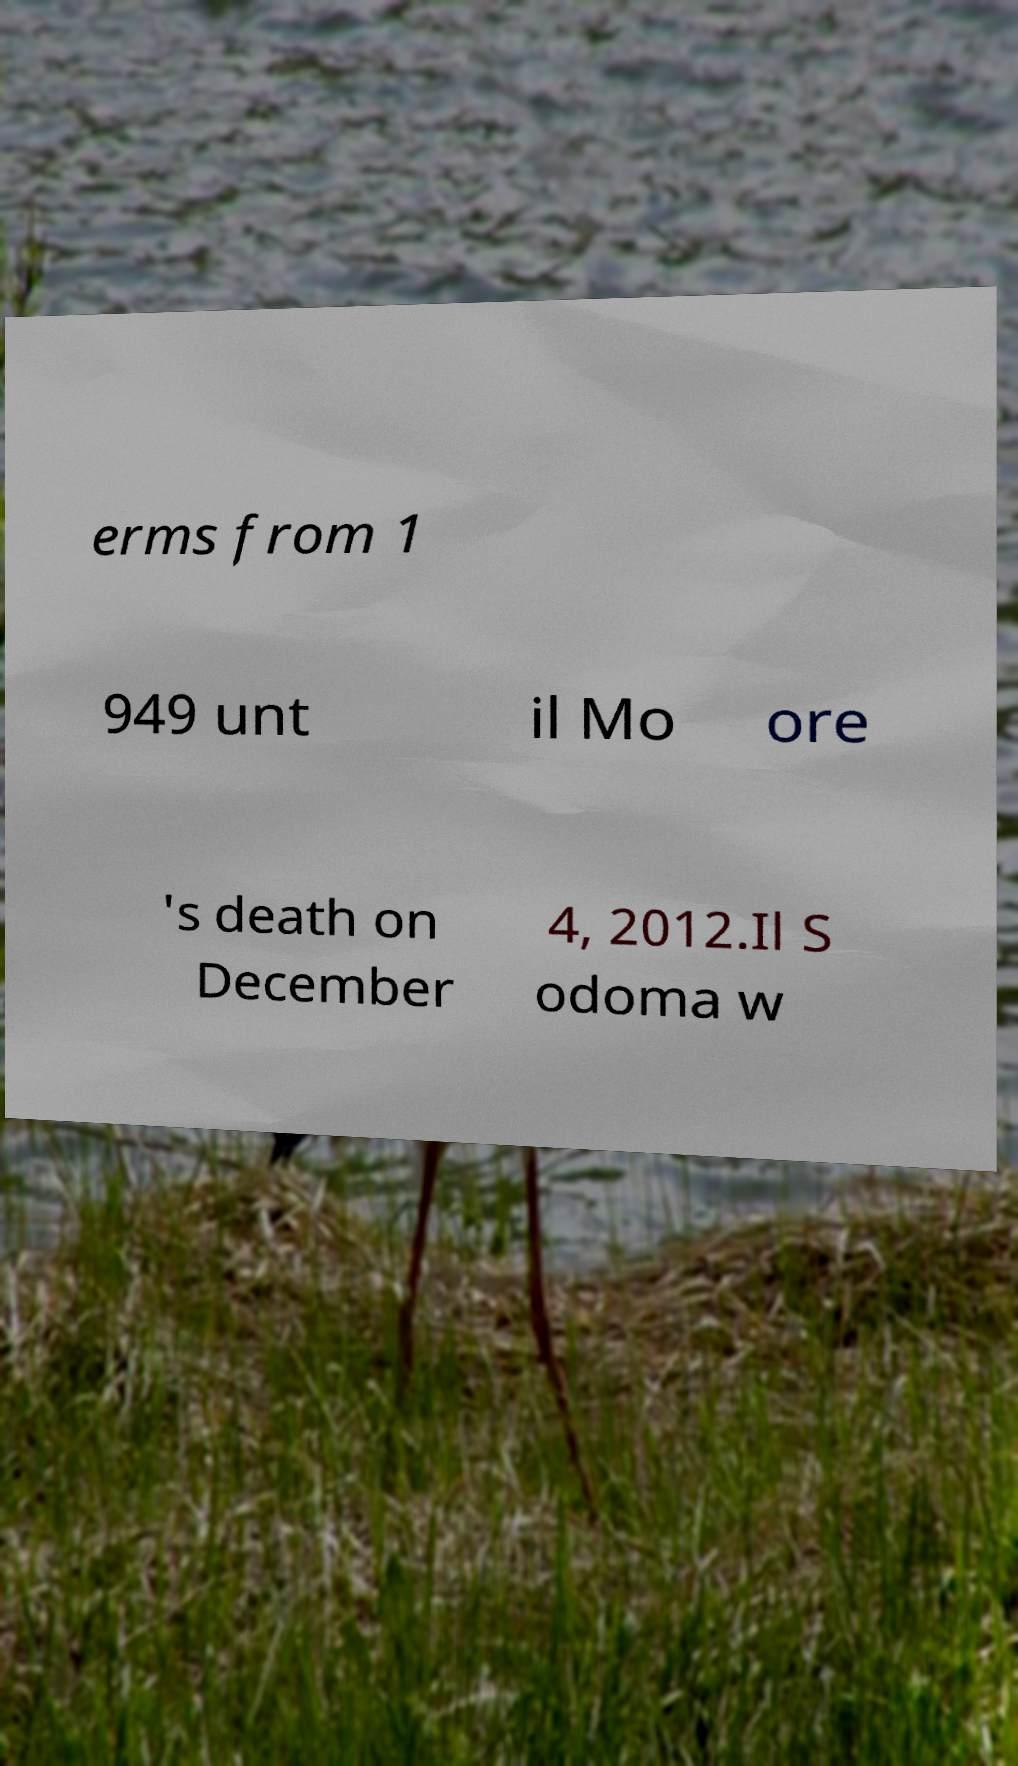There's text embedded in this image that I need extracted. Can you transcribe it verbatim? erms from 1 949 unt il Mo ore 's death on December 4, 2012.Il S odoma w 